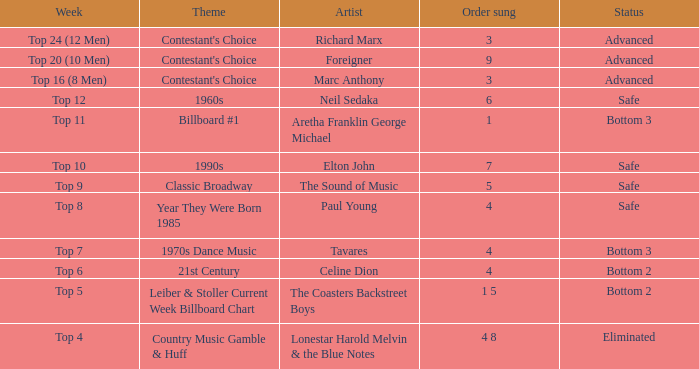When did the contestant land in the bottom 2 as a result of singing a celine dion song? Top 6. 